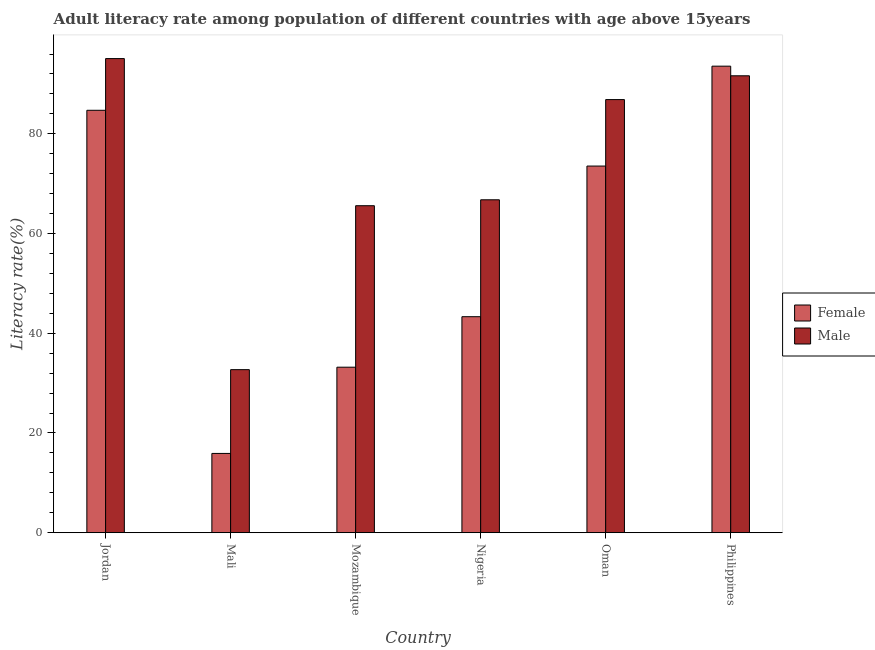How many different coloured bars are there?
Provide a succinct answer. 2. How many groups of bars are there?
Give a very brief answer. 6. Are the number of bars on each tick of the X-axis equal?
Provide a succinct answer. Yes. What is the label of the 5th group of bars from the left?
Your response must be concise. Oman. In how many cases, is the number of bars for a given country not equal to the number of legend labels?
Ensure brevity in your answer.  0. What is the male adult literacy rate in Jordan?
Ensure brevity in your answer.  95.08. Across all countries, what is the maximum female adult literacy rate?
Make the answer very short. 93.56. Across all countries, what is the minimum female adult literacy rate?
Ensure brevity in your answer.  15.9. In which country was the male adult literacy rate maximum?
Keep it short and to the point. Jordan. In which country was the male adult literacy rate minimum?
Your answer should be very brief. Mali. What is the total male adult literacy rate in the graph?
Offer a very short reply. 438.63. What is the difference between the female adult literacy rate in Mozambique and that in Oman?
Offer a very short reply. -40.34. What is the difference between the female adult literacy rate in Oman and the male adult literacy rate in Philippines?
Give a very brief answer. -18.1. What is the average male adult literacy rate per country?
Make the answer very short. 73.1. What is the difference between the female adult literacy rate and male adult literacy rate in Jordan?
Ensure brevity in your answer.  -10.37. In how many countries, is the female adult literacy rate greater than 84 %?
Your response must be concise. 2. What is the ratio of the female adult literacy rate in Oman to that in Philippines?
Ensure brevity in your answer.  0.79. Is the female adult literacy rate in Mozambique less than that in Oman?
Make the answer very short. Yes. What is the difference between the highest and the second highest female adult literacy rate?
Your answer should be compact. 8.85. What is the difference between the highest and the lowest male adult literacy rate?
Ensure brevity in your answer.  62.38. In how many countries, is the male adult literacy rate greater than the average male adult literacy rate taken over all countries?
Keep it short and to the point. 3. Is the sum of the female adult literacy rate in Nigeria and Oman greater than the maximum male adult literacy rate across all countries?
Your answer should be compact. Yes. What does the 1st bar from the left in Jordan represents?
Your answer should be very brief. Female. What does the 2nd bar from the right in Oman represents?
Give a very brief answer. Female. Are all the bars in the graph horizontal?
Your answer should be very brief. No. What is the difference between two consecutive major ticks on the Y-axis?
Make the answer very short. 20. Does the graph contain any zero values?
Offer a terse response. No. Does the graph contain grids?
Provide a short and direct response. No. Where does the legend appear in the graph?
Provide a short and direct response. Center right. How many legend labels are there?
Offer a very short reply. 2. What is the title of the graph?
Offer a terse response. Adult literacy rate among population of different countries with age above 15years. What is the label or title of the Y-axis?
Offer a very short reply. Literacy rate(%). What is the Literacy rate(%) in Female in Jordan?
Give a very brief answer. 84.71. What is the Literacy rate(%) in Male in Jordan?
Offer a very short reply. 95.08. What is the Literacy rate(%) in Female in Mali?
Ensure brevity in your answer.  15.9. What is the Literacy rate(%) of Male in Mali?
Offer a very short reply. 32.7. What is the Literacy rate(%) of Female in Mozambique?
Your response must be concise. 33.19. What is the Literacy rate(%) of Male in Mozambique?
Offer a terse response. 65.58. What is the Literacy rate(%) of Female in Nigeria?
Offer a very short reply. 43.32. What is the Literacy rate(%) in Male in Nigeria?
Your answer should be compact. 66.77. What is the Literacy rate(%) in Female in Oman?
Your answer should be very brief. 73.53. What is the Literacy rate(%) of Male in Oman?
Offer a very short reply. 86.86. What is the Literacy rate(%) in Female in Philippines?
Keep it short and to the point. 93.56. What is the Literacy rate(%) in Male in Philippines?
Give a very brief answer. 91.63. Across all countries, what is the maximum Literacy rate(%) in Female?
Provide a succinct answer. 93.56. Across all countries, what is the maximum Literacy rate(%) of Male?
Your answer should be very brief. 95.08. Across all countries, what is the minimum Literacy rate(%) of Female?
Offer a very short reply. 15.9. Across all countries, what is the minimum Literacy rate(%) of Male?
Offer a very short reply. 32.7. What is the total Literacy rate(%) in Female in the graph?
Your response must be concise. 344.23. What is the total Literacy rate(%) of Male in the graph?
Make the answer very short. 438.63. What is the difference between the Literacy rate(%) in Female in Jordan and that in Mali?
Your response must be concise. 68.81. What is the difference between the Literacy rate(%) of Male in Jordan and that in Mali?
Make the answer very short. 62.38. What is the difference between the Literacy rate(%) in Female in Jordan and that in Mozambique?
Offer a terse response. 51.52. What is the difference between the Literacy rate(%) in Male in Jordan and that in Mozambique?
Give a very brief answer. 29.51. What is the difference between the Literacy rate(%) of Female in Jordan and that in Nigeria?
Offer a terse response. 41.39. What is the difference between the Literacy rate(%) in Male in Jordan and that in Nigeria?
Offer a terse response. 28.32. What is the difference between the Literacy rate(%) in Female in Jordan and that in Oman?
Give a very brief answer. 11.18. What is the difference between the Literacy rate(%) in Male in Jordan and that in Oman?
Make the answer very short. 8.22. What is the difference between the Literacy rate(%) of Female in Jordan and that in Philippines?
Make the answer very short. -8.85. What is the difference between the Literacy rate(%) of Male in Jordan and that in Philippines?
Offer a terse response. 3.45. What is the difference between the Literacy rate(%) in Female in Mali and that in Mozambique?
Make the answer very short. -17.29. What is the difference between the Literacy rate(%) in Male in Mali and that in Mozambique?
Offer a very short reply. -32.88. What is the difference between the Literacy rate(%) of Female in Mali and that in Nigeria?
Keep it short and to the point. -27.42. What is the difference between the Literacy rate(%) of Male in Mali and that in Nigeria?
Provide a short and direct response. -34.07. What is the difference between the Literacy rate(%) in Female in Mali and that in Oman?
Keep it short and to the point. -57.63. What is the difference between the Literacy rate(%) of Male in Mali and that in Oman?
Your answer should be compact. -54.16. What is the difference between the Literacy rate(%) of Female in Mali and that in Philippines?
Make the answer very short. -77.66. What is the difference between the Literacy rate(%) of Male in Mali and that in Philippines?
Ensure brevity in your answer.  -58.93. What is the difference between the Literacy rate(%) in Female in Mozambique and that in Nigeria?
Make the answer very short. -10.13. What is the difference between the Literacy rate(%) in Male in Mozambique and that in Nigeria?
Provide a short and direct response. -1.19. What is the difference between the Literacy rate(%) of Female in Mozambique and that in Oman?
Keep it short and to the point. -40.34. What is the difference between the Literacy rate(%) in Male in Mozambique and that in Oman?
Provide a short and direct response. -21.29. What is the difference between the Literacy rate(%) of Female in Mozambique and that in Philippines?
Make the answer very short. -60.37. What is the difference between the Literacy rate(%) of Male in Mozambique and that in Philippines?
Make the answer very short. -26.06. What is the difference between the Literacy rate(%) in Female in Nigeria and that in Oman?
Ensure brevity in your answer.  -30.21. What is the difference between the Literacy rate(%) of Male in Nigeria and that in Oman?
Offer a terse response. -20.09. What is the difference between the Literacy rate(%) in Female in Nigeria and that in Philippines?
Your answer should be compact. -50.24. What is the difference between the Literacy rate(%) in Male in Nigeria and that in Philippines?
Keep it short and to the point. -24.87. What is the difference between the Literacy rate(%) in Female in Oman and that in Philippines?
Your response must be concise. -20.03. What is the difference between the Literacy rate(%) in Male in Oman and that in Philippines?
Keep it short and to the point. -4.77. What is the difference between the Literacy rate(%) of Female in Jordan and the Literacy rate(%) of Male in Mali?
Keep it short and to the point. 52.01. What is the difference between the Literacy rate(%) of Female in Jordan and the Literacy rate(%) of Male in Mozambique?
Ensure brevity in your answer.  19.14. What is the difference between the Literacy rate(%) of Female in Jordan and the Literacy rate(%) of Male in Nigeria?
Offer a very short reply. 17.95. What is the difference between the Literacy rate(%) of Female in Jordan and the Literacy rate(%) of Male in Oman?
Give a very brief answer. -2.15. What is the difference between the Literacy rate(%) of Female in Jordan and the Literacy rate(%) of Male in Philippines?
Ensure brevity in your answer.  -6.92. What is the difference between the Literacy rate(%) of Female in Mali and the Literacy rate(%) of Male in Mozambique?
Ensure brevity in your answer.  -49.68. What is the difference between the Literacy rate(%) of Female in Mali and the Literacy rate(%) of Male in Nigeria?
Your answer should be very brief. -50.87. What is the difference between the Literacy rate(%) in Female in Mali and the Literacy rate(%) in Male in Oman?
Provide a short and direct response. -70.96. What is the difference between the Literacy rate(%) in Female in Mali and the Literacy rate(%) in Male in Philippines?
Keep it short and to the point. -75.73. What is the difference between the Literacy rate(%) in Female in Mozambique and the Literacy rate(%) in Male in Nigeria?
Provide a succinct answer. -33.57. What is the difference between the Literacy rate(%) in Female in Mozambique and the Literacy rate(%) in Male in Oman?
Offer a very short reply. -53.67. What is the difference between the Literacy rate(%) of Female in Mozambique and the Literacy rate(%) of Male in Philippines?
Make the answer very short. -58.44. What is the difference between the Literacy rate(%) in Female in Nigeria and the Literacy rate(%) in Male in Oman?
Keep it short and to the point. -43.54. What is the difference between the Literacy rate(%) of Female in Nigeria and the Literacy rate(%) of Male in Philippines?
Keep it short and to the point. -48.31. What is the difference between the Literacy rate(%) in Female in Oman and the Literacy rate(%) in Male in Philippines?
Ensure brevity in your answer.  -18.1. What is the average Literacy rate(%) of Female per country?
Make the answer very short. 57.37. What is the average Literacy rate(%) in Male per country?
Your answer should be very brief. 73.1. What is the difference between the Literacy rate(%) of Female and Literacy rate(%) of Male in Jordan?
Your answer should be very brief. -10.37. What is the difference between the Literacy rate(%) in Female and Literacy rate(%) in Male in Mali?
Make the answer very short. -16.8. What is the difference between the Literacy rate(%) in Female and Literacy rate(%) in Male in Mozambique?
Your answer should be very brief. -32.38. What is the difference between the Literacy rate(%) in Female and Literacy rate(%) in Male in Nigeria?
Give a very brief answer. -23.45. What is the difference between the Literacy rate(%) in Female and Literacy rate(%) in Male in Oman?
Your answer should be compact. -13.33. What is the difference between the Literacy rate(%) of Female and Literacy rate(%) of Male in Philippines?
Provide a short and direct response. 1.93. What is the ratio of the Literacy rate(%) of Female in Jordan to that in Mali?
Offer a terse response. 5.33. What is the ratio of the Literacy rate(%) of Male in Jordan to that in Mali?
Offer a terse response. 2.91. What is the ratio of the Literacy rate(%) of Female in Jordan to that in Mozambique?
Keep it short and to the point. 2.55. What is the ratio of the Literacy rate(%) of Male in Jordan to that in Mozambique?
Make the answer very short. 1.45. What is the ratio of the Literacy rate(%) of Female in Jordan to that in Nigeria?
Ensure brevity in your answer.  1.96. What is the ratio of the Literacy rate(%) in Male in Jordan to that in Nigeria?
Ensure brevity in your answer.  1.42. What is the ratio of the Literacy rate(%) of Female in Jordan to that in Oman?
Offer a terse response. 1.15. What is the ratio of the Literacy rate(%) in Male in Jordan to that in Oman?
Your answer should be compact. 1.09. What is the ratio of the Literacy rate(%) of Female in Jordan to that in Philippines?
Offer a terse response. 0.91. What is the ratio of the Literacy rate(%) of Male in Jordan to that in Philippines?
Offer a terse response. 1.04. What is the ratio of the Literacy rate(%) in Female in Mali to that in Mozambique?
Offer a terse response. 0.48. What is the ratio of the Literacy rate(%) in Male in Mali to that in Mozambique?
Offer a very short reply. 0.5. What is the ratio of the Literacy rate(%) in Female in Mali to that in Nigeria?
Your answer should be very brief. 0.37. What is the ratio of the Literacy rate(%) of Male in Mali to that in Nigeria?
Provide a succinct answer. 0.49. What is the ratio of the Literacy rate(%) in Female in Mali to that in Oman?
Your answer should be compact. 0.22. What is the ratio of the Literacy rate(%) of Male in Mali to that in Oman?
Make the answer very short. 0.38. What is the ratio of the Literacy rate(%) of Female in Mali to that in Philippines?
Offer a terse response. 0.17. What is the ratio of the Literacy rate(%) in Male in Mali to that in Philippines?
Your answer should be very brief. 0.36. What is the ratio of the Literacy rate(%) in Female in Mozambique to that in Nigeria?
Keep it short and to the point. 0.77. What is the ratio of the Literacy rate(%) in Male in Mozambique to that in Nigeria?
Make the answer very short. 0.98. What is the ratio of the Literacy rate(%) of Female in Mozambique to that in Oman?
Your answer should be compact. 0.45. What is the ratio of the Literacy rate(%) of Male in Mozambique to that in Oman?
Offer a terse response. 0.76. What is the ratio of the Literacy rate(%) of Female in Mozambique to that in Philippines?
Your answer should be compact. 0.35. What is the ratio of the Literacy rate(%) of Male in Mozambique to that in Philippines?
Make the answer very short. 0.72. What is the ratio of the Literacy rate(%) of Female in Nigeria to that in Oman?
Make the answer very short. 0.59. What is the ratio of the Literacy rate(%) of Male in Nigeria to that in Oman?
Your answer should be compact. 0.77. What is the ratio of the Literacy rate(%) in Female in Nigeria to that in Philippines?
Offer a very short reply. 0.46. What is the ratio of the Literacy rate(%) in Male in Nigeria to that in Philippines?
Offer a very short reply. 0.73. What is the ratio of the Literacy rate(%) of Female in Oman to that in Philippines?
Make the answer very short. 0.79. What is the ratio of the Literacy rate(%) of Male in Oman to that in Philippines?
Offer a terse response. 0.95. What is the difference between the highest and the second highest Literacy rate(%) of Female?
Your response must be concise. 8.85. What is the difference between the highest and the second highest Literacy rate(%) of Male?
Give a very brief answer. 3.45. What is the difference between the highest and the lowest Literacy rate(%) of Female?
Your response must be concise. 77.66. What is the difference between the highest and the lowest Literacy rate(%) of Male?
Provide a succinct answer. 62.38. 